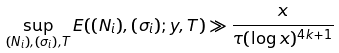<formula> <loc_0><loc_0><loc_500><loc_500>\sup _ { ( N _ { i } ) , ( \sigma _ { i } ) , T } E ( ( N _ { i } ) , ( \sigma _ { i } ) ; y , T ) \gg \frac { x } { \tau ( \log { x } ) ^ { 4 k + 1 } }</formula> 